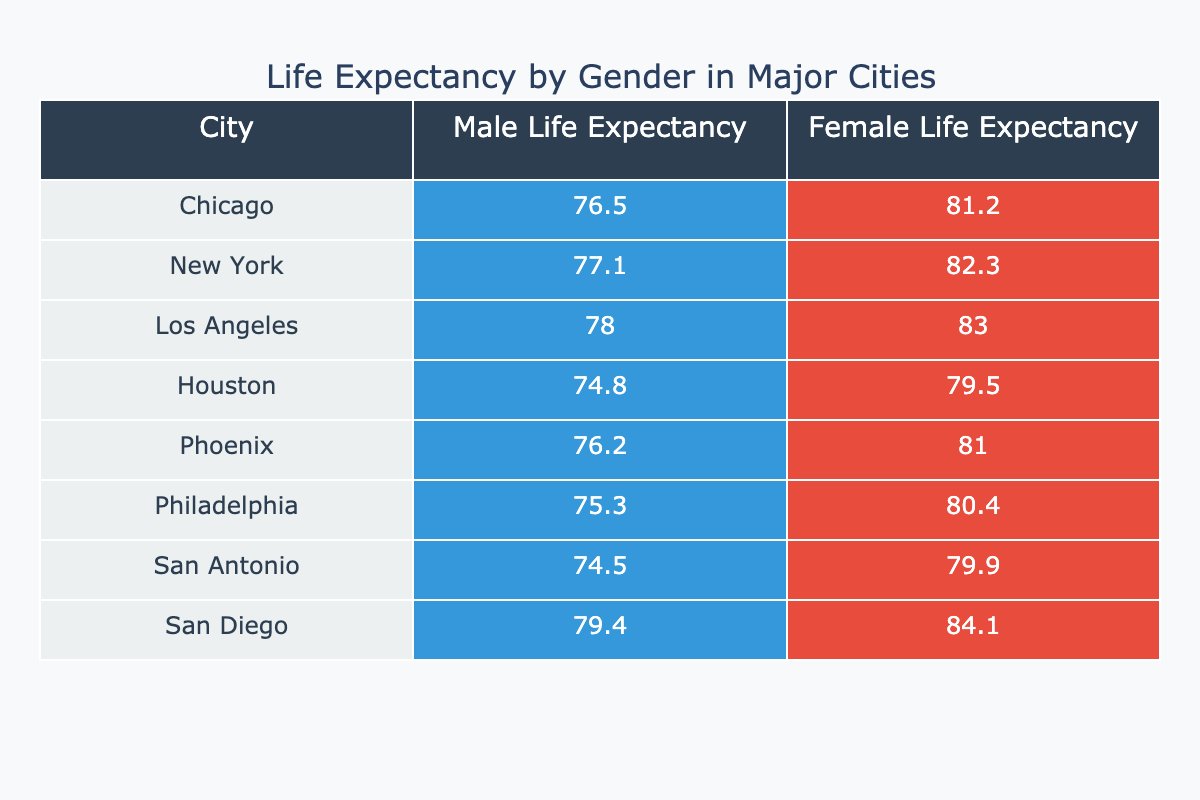What is the life expectancy for females in Chicago? The table shows that the life expectancy for females in Chicago is listed under the Female Life Expectancy column for that city, which is 81.2 years.
Answer: 81.2 What is the life expectancy difference between males and females in New York? For New York, the life expectancy for males is 77.1 years and for females is 82.3 years. The difference is calculated as 82.3 - 77.1 = 5.2 years.
Answer: 5.2 Is the life expectancy for females in San Diego higher than that in Los Angeles? The life expectancy for females in San Diego is 84.1 years and in Los Angeles is 83.0 years. Since 84.1 is greater than 83.0, the statement is true.
Answer: Yes Which city has the lowest male life expectancy? By examining the Male Life Expectancy column, we find Houston at 74.8 years has the lowest value when compared to other cities.
Answer: Houston What is the average male life expectancy across all cities? First, we need to sum all male life expectancies: 76.5 + 77.1 + 78.0 + 74.8 + 76.2 + 75.3 + 74.5 + 79.4 = 600.4. There are 8 cities, so the average male life expectancy is 600.4 / 8 = 75.05 years.
Answer: 75.05 Is the life expectancy for males in Chicago greater than that in Philadelphia? The life expectancy for males in Chicago is 76.5 years, while in Philadelphia it is 75.3 years. Since 76.5 is greater than 75.3, the answer is true.
Answer: Yes What is the highest life expectancy for females among these cities? By searching through the Female Life Expectancy column, we find that San Diego has the highest value at 84.1 years.
Answer: 84.1 Calculate the total life expectancy for both genders combined in Los Angeles. For Los Angeles, the male life expectancy is 78.0 years and the female life expectancy is 83.0 years. Adding these two together: 78.0 + 83.0 = 161.0 years gives us the total combined life expectancy.
Answer: 161.0 Which city has the largest gap between male and female life expectancy? We compare the differences: Chicago (4.7), New York (5.2), Los Angeles (5.0), Houston (4.7), Phoenix (4.8), Philadelphia (5.1), San Antonio (5.4), San Diego (4.7). The largest gap is in San Antonio at 5.4 years.
Answer: San Antonio 